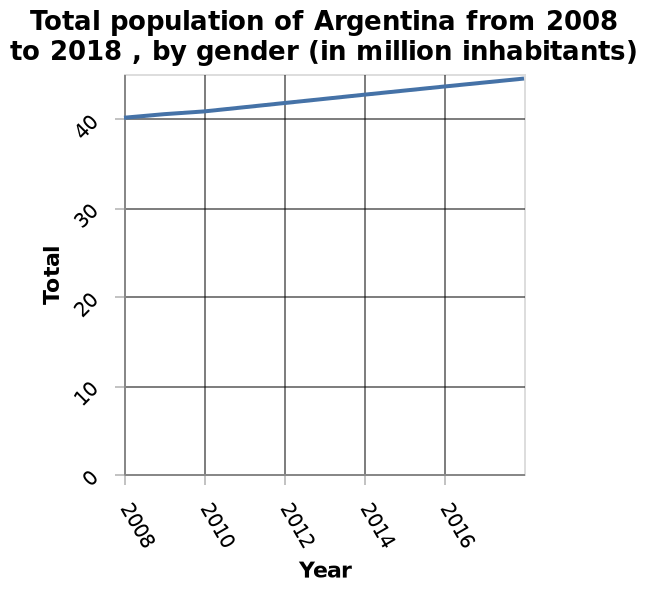<image>
What is the range of values on the y-axis?  The range of values on the y-axis is from 0 to 40. Is there a correlation between the increase in the total and the number of years?  Yes, there is a steady correlation between the increase in the total and the number of years. What does the line graph represent? The line graph represents the total population of Argentina over the years 2008 to 2018, categorized by gender, with the population measured in million inhabitants. 